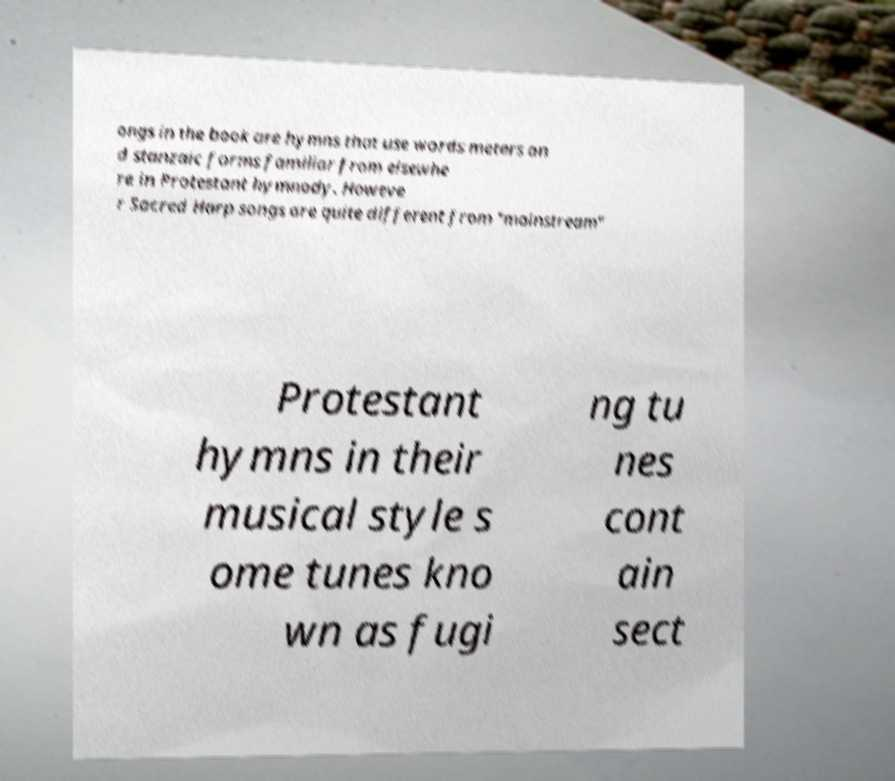Can you read and provide the text displayed in the image?This photo seems to have some interesting text. Can you extract and type it out for me? ongs in the book are hymns that use words meters an d stanzaic forms familiar from elsewhe re in Protestant hymnody. Howeve r Sacred Harp songs are quite different from "mainstream" Protestant hymns in their musical style s ome tunes kno wn as fugi ng tu nes cont ain sect 